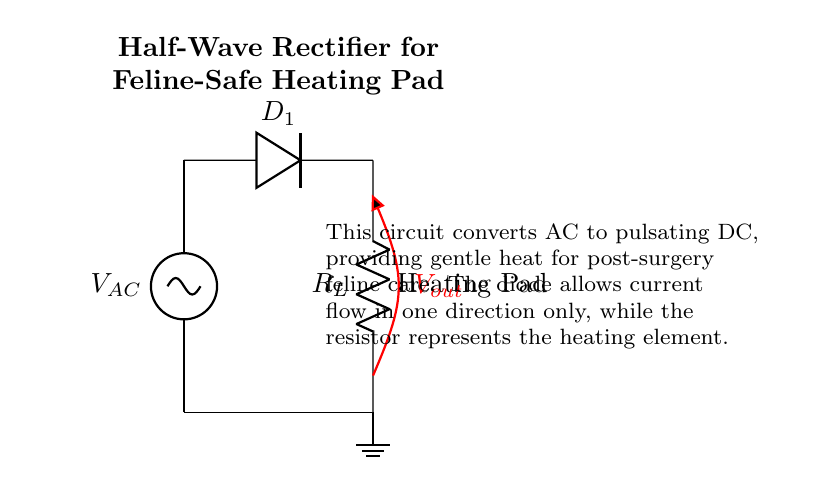What type of rectifier is shown in this circuit diagram? The diagram illustrates a half-wave rectifier circuit, which is characterized by a single diode allowing current to pass only during one half of the AC cycle.
Answer: Half-wave What component in the circuit provides heating? The load resistor represents the heating element (heating pad), which converts electrical energy into heat for post-surgery care.
Answer: Heating pad How many diodes are present in the circuit? The circuit diagram depicts only one diode, which is sufficient for the half-wave rectification process, allowing current to flow in one direction.
Answer: One What is the purpose of the diode in this circuit? The diode allows current to flow only during the positive half of the AC cycle, blocking the negative half, which is essential for converting AC to DC in this application.
Answer: Convert AC to DC What does the output voltage represent in this circuit? The output voltage is the pulsating DC that is generated across the heating pad, providing the necessary power for gentle heating.
Answer: Pulsating DC What does the ground connection signify in the circuit? The ground connection provides a reference point for the circuit's voltage levels, ensuring safety and proper functioning of the heating pad during operation.
Answer: Reference point 